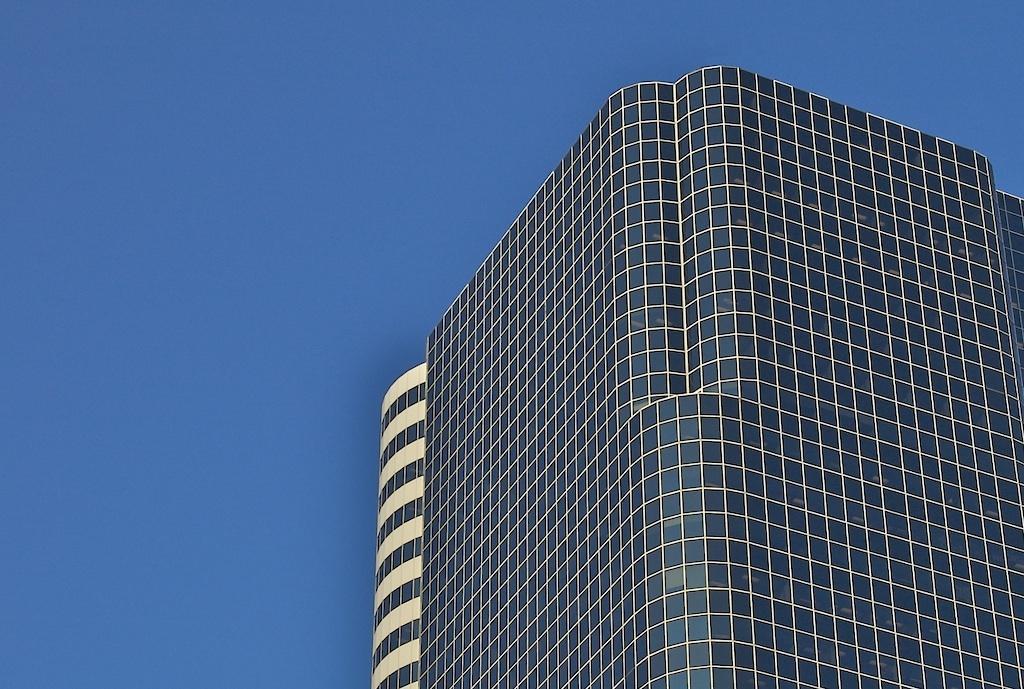In one or two sentences, can you explain what this image depicts? On the right side, there are buildings having glass windows. In the background, there is blue sky. 